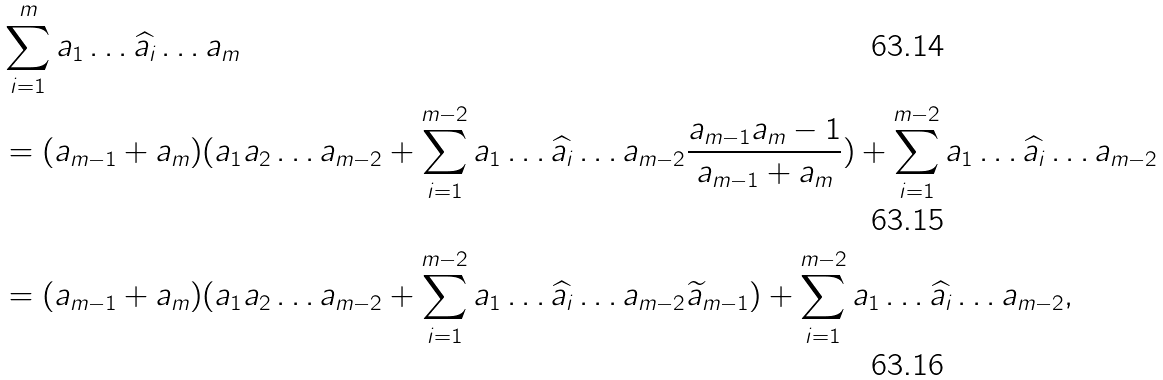Convert formula to latex. <formula><loc_0><loc_0><loc_500><loc_500>& \sum _ { i = 1 } ^ { m } a _ { 1 } \dots \widehat { a _ { i } } \dots a _ { m } \\ & = ( a _ { m - 1 } + a _ { m } ) ( a _ { 1 } a _ { 2 } \dots a _ { m - 2 } + \sum _ { i = 1 } ^ { m - 2 } a _ { 1 } \dots \widehat { a _ { i } } \dots a _ { m - 2 } \frac { a _ { m - 1 } a _ { m } - 1 } { a _ { m - 1 } + a _ { m } } ) + \sum _ { i = 1 } ^ { m - 2 } a _ { 1 } \dots \widehat { a _ { i } } \dots a _ { m - 2 } \\ & = ( a _ { m - 1 } + a _ { m } ) ( a _ { 1 } a _ { 2 } \dots a _ { m - 2 } + \sum _ { i = 1 } ^ { m - 2 } a _ { 1 } \dots \widehat { a _ { i } } \dots a _ { m - 2 } \widetilde { a } _ { m - 1 } ) + \sum _ { i = 1 } ^ { m - 2 } a _ { 1 } \dots \widehat { a _ { i } } \dots a _ { m - 2 } ,</formula> 